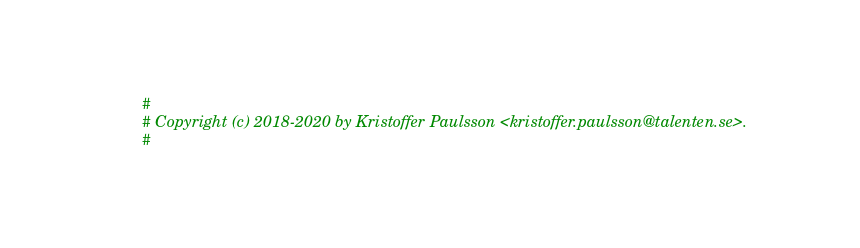<code> <loc_0><loc_0><loc_500><loc_500><_Cython_>#
# Copyright (c) 2018-2020 by Kristoffer Paulsson <kristoffer.paulsson@talenten.se>.
#</code> 